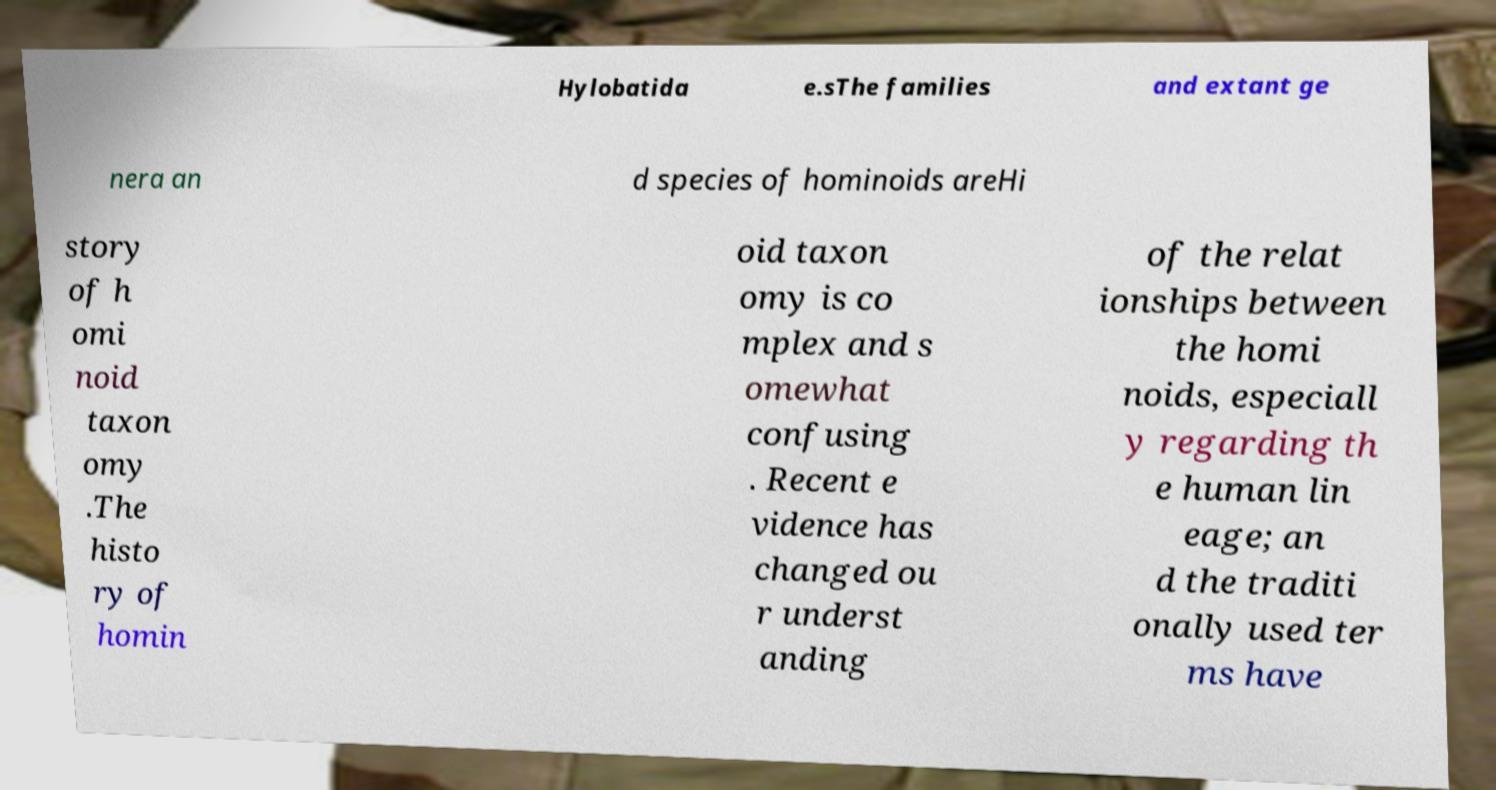Could you extract and type out the text from this image? Hylobatida e.sThe families and extant ge nera an d species of hominoids areHi story of h omi noid taxon omy .The histo ry of homin oid taxon omy is co mplex and s omewhat confusing . Recent e vidence has changed ou r underst anding of the relat ionships between the homi noids, especiall y regarding th e human lin eage; an d the traditi onally used ter ms have 